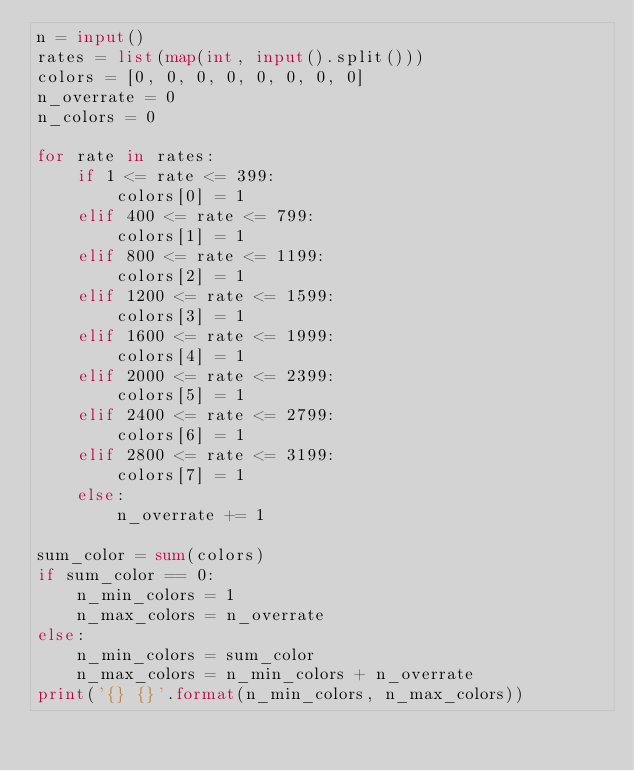<code> <loc_0><loc_0><loc_500><loc_500><_Python_>n = input()
rates = list(map(int, input().split()))
colors = [0, 0, 0, 0, 0, 0, 0, 0]
n_overrate = 0
n_colors = 0

for rate in rates:
    if 1 <= rate <= 399:
        colors[0] = 1
    elif 400 <= rate <= 799:
        colors[1] = 1
    elif 800 <= rate <= 1199:
        colors[2] = 1
    elif 1200 <= rate <= 1599:
        colors[3] = 1
    elif 1600 <= rate <= 1999:
        colors[4] = 1
    elif 2000 <= rate <= 2399:
        colors[5] = 1
    elif 2400 <= rate <= 2799:
        colors[6] = 1
    elif 2800 <= rate <= 3199:
        colors[7] = 1
    else:
        n_overrate += 1

sum_color = sum(colors)
if sum_color == 0:
    n_min_colors = 1
    n_max_colors = n_overrate
else:
    n_min_colors = sum_color
    n_max_colors = n_min_colors + n_overrate
print('{} {}'.format(n_min_colors, n_max_colors))
</code> 